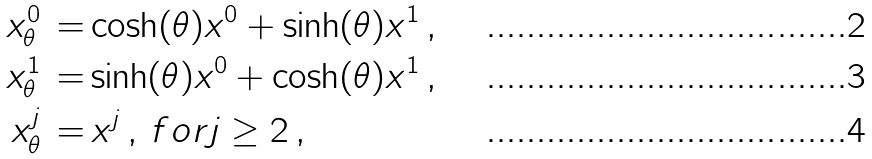<formula> <loc_0><loc_0><loc_500><loc_500>x _ { \theta } ^ { 0 } \, = & \cosh ( \theta ) x ^ { 0 } + \sinh ( \theta ) x ^ { 1 } \, , \\ x _ { \theta } ^ { 1 } \, = & \sinh ( \theta ) x ^ { 0 } + \cosh ( \theta ) x ^ { 1 } \, , \\ x _ { \theta } ^ { j } \, = & \, x ^ { j } \, , \, f o r j \geq 2 \, ,</formula> 